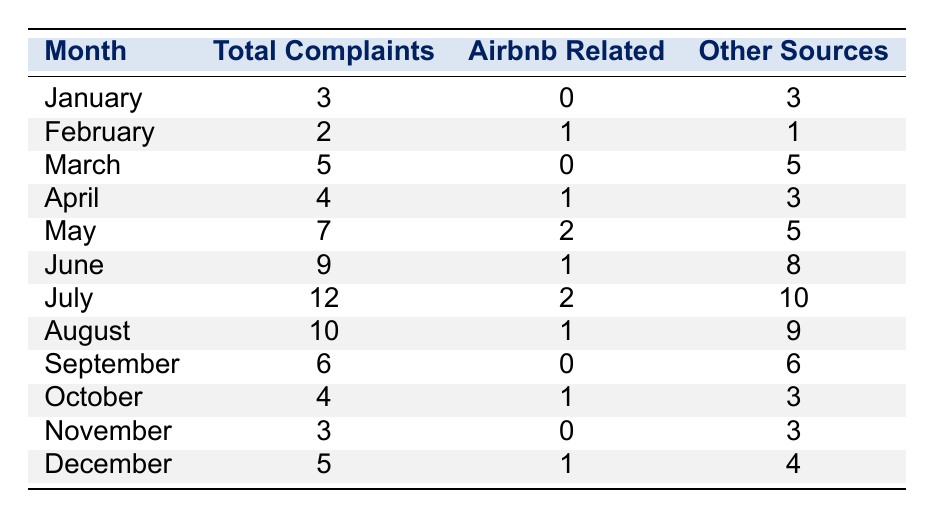What was the total number of complaints in July? In July, the table shows that the total number of complaints was listed as 12.
Answer: 12 How many Airbnb-related complaints were reported in February? The table indicates that there was 1 Airbnb-related complaint in February.
Answer: 1 What is the month with the highest number of complaints? Looking at the table, July has the highest total complaints at 12.
Answer: July In which month were there no Airbnb-related complaints? The months of January, March, September, and November all show 0 Airbnb-related complaints according to the table.
Answer: January, March, September, November What is the difference in total complaints between March and June? March has 5 total complaints, and June has 9 total complaints. The difference is 9 - 5 = 4.
Answer: 4 What was the average number of Airbnb-related complaints per month over the year? Adding all Airbnb-related complaints (0 + 1 + 0 + 1 + 2 + 1 + 2 + 1 + 0 + 1 + 0 + 1) gives 10. Dividing by 12 months gives 10/12 = 0.83 (approximately).
Answer: 0.83 Were there more total complaints in the second half of the year compared to the first half? First half: January (3) + February (2) + March (5) + April (4) + May (7) + June (9) = 30. Second half: July (12) + August (10) + September (6) + October (4) + November (3) + December (5) = 40. Since 40 is greater than 30, yes, there were more complaints in the second half.
Answer: Yes What is the total number of other sources complaints for the entire year? Summing other sources complaints: 3 + 1 + 5 + 3 + 5 + 8 + 10 + 9 + 6 + 3 + 4 gives a total of 57.
Answer: 57 How many months had a total of 4 or fewer complaints? The months with 4 or fewer complaints are January (3), February (2), and March (5), making a total of 3 months: January, February, and October.
Answer: 3 Was December the month with the least number of total complaints? December had 5 total complaints, while both January (3) and February (2) had fewer, thus December was not the month with the least complaints.
Answer: No 